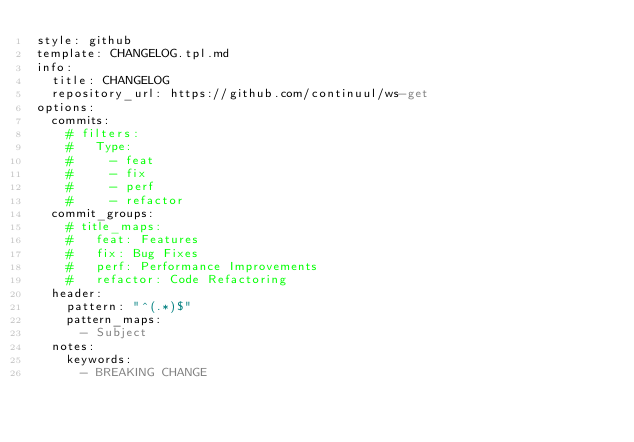Convert code to text. <code><loc_0><loc_0><loc_500><loc_500><_YAML_>style: github
template: CHANGELOG.tpl.md
info:
  title: CHANGELOG
  repository_url: https://github.com/continuul/ws-get
options:
  commits:
    # filters:
    #   Type:
    #     - feat
    #     - fix
    #     - perf
    #     - refactor
  commit_groups:
    # title_maps:
    #   feat: Features
    #   fix: Bug Fixes
    #   perf: Performance Improvements
    #   refactor: Code Refactoring
  header:
    pattern: "^(.*)$"
    pattern_maps:
      - Subject
  notes:
    keywords:
      - BREAKING CHANGE
</code> 